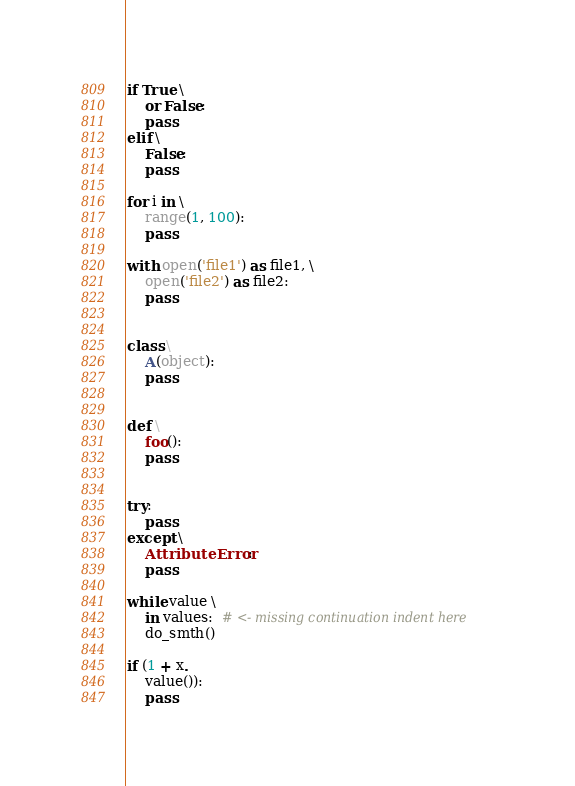<code> <loc_0><loc_0><loc_500><loc_500><_Python_>if True \
    or False:
    pass
elif \
    False:
    pass

for i in \
    range(1, 100):
    pass

with open('file1') as file1, \
    open('file2') as file2:
    pass


class \
    A(object):
    pass


def \
    foo():
    pass


try:
    pass
except \
    AttributeError:
    pass

while value \
    in values:  # <- missing continuation indent here
    do_smth()

if (1 + x.
    value()):
    pass</code> 